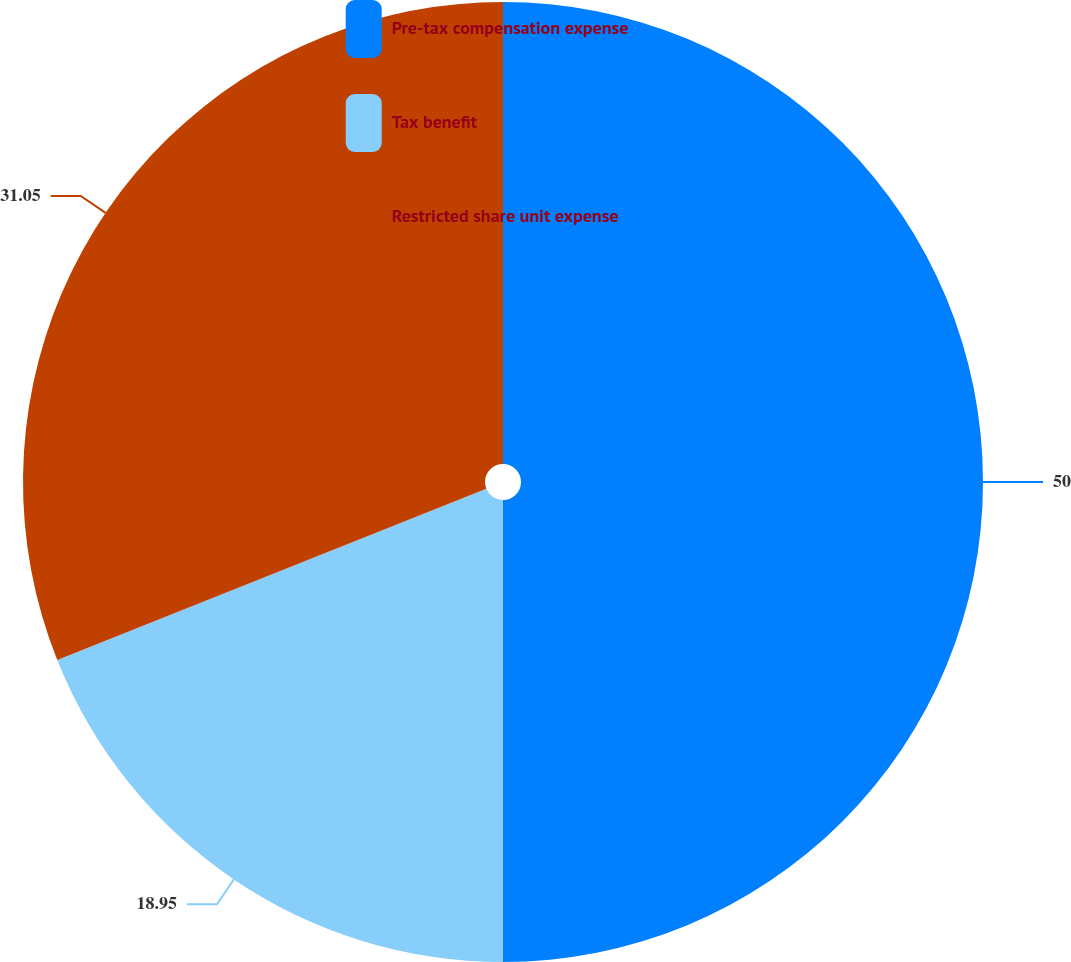Convert chart to OTSL. <chart><loc_0><loc_0><loc_500><loc_500><pie_chart><fcel>Pre-tax compensation expense<fcel>Tax benefit<fcel>Restricted share unit expense<nl><fcel>50.0%<fcel>18.95%<fcel>31.05%<nl></chart> 